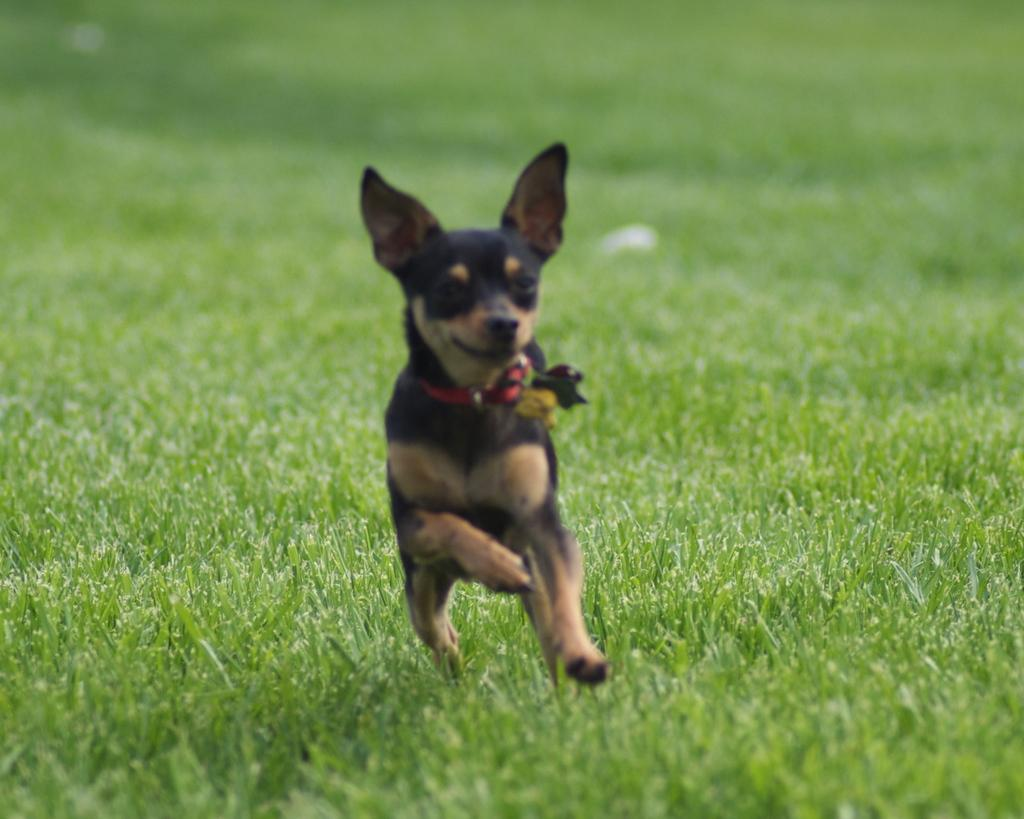What animal is present in the image? There is a dog in the image. What is the dog doing in the image? The dog is running in the image. Where is the dog running on? The dog is running on the grass in the image. What type of loaf is the dog carrying in its mouth in the image? There is no loaf present in the image; the dog is running on the grass without carrying anything in its mouth. 